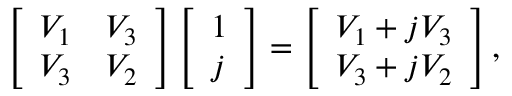<formula> <loc_0><loc_0><loc_500><loc_500>\left [ \begin{array} { l l } { V _ { 1 } } & { V _ { 3 } } \\ { V _ { 3 } } & { V _ { 2 } } \end{array} \right ] \left [ \begin{array} { l } { 1 } \\ { j } \end{array} \right ] = \left [ \begin{array} { l } { V _ { 1 } + j V _ { 3 } } \\ { V _ { 3 } + j V _ { 2 } } \end{array} \right ] ,</formula> 